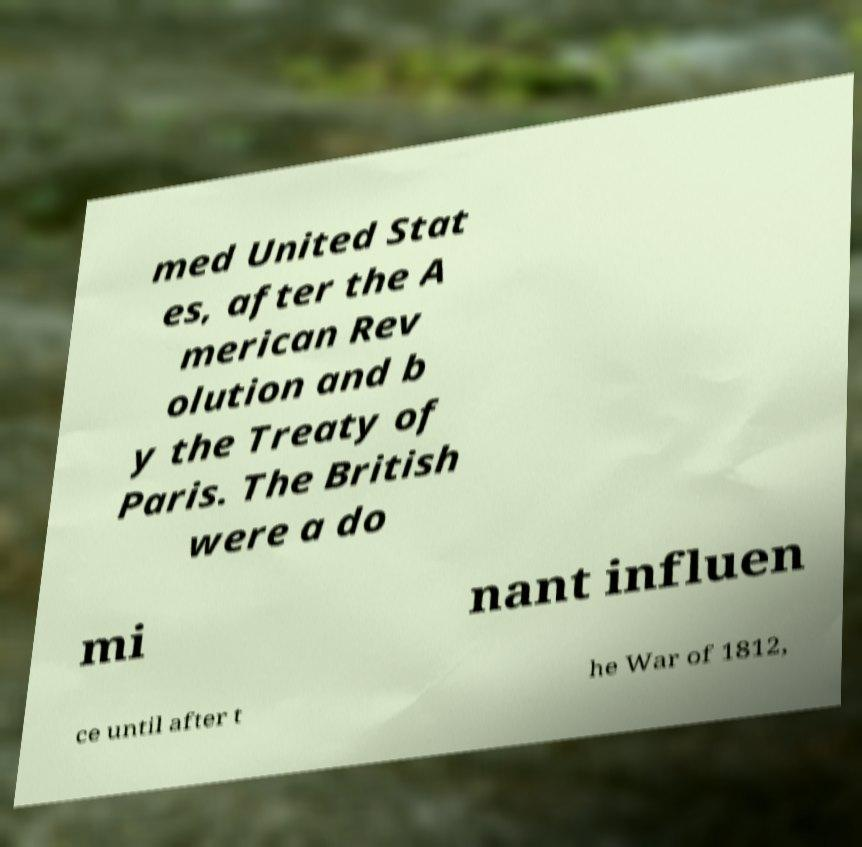Could you assist in decoding the text presented in this image and type it out clearly? med United Stat es, after the A merican Rev olution and b y the Treaty of Paris. The British were a do mi nant influen ce until after t he War of 1812, 